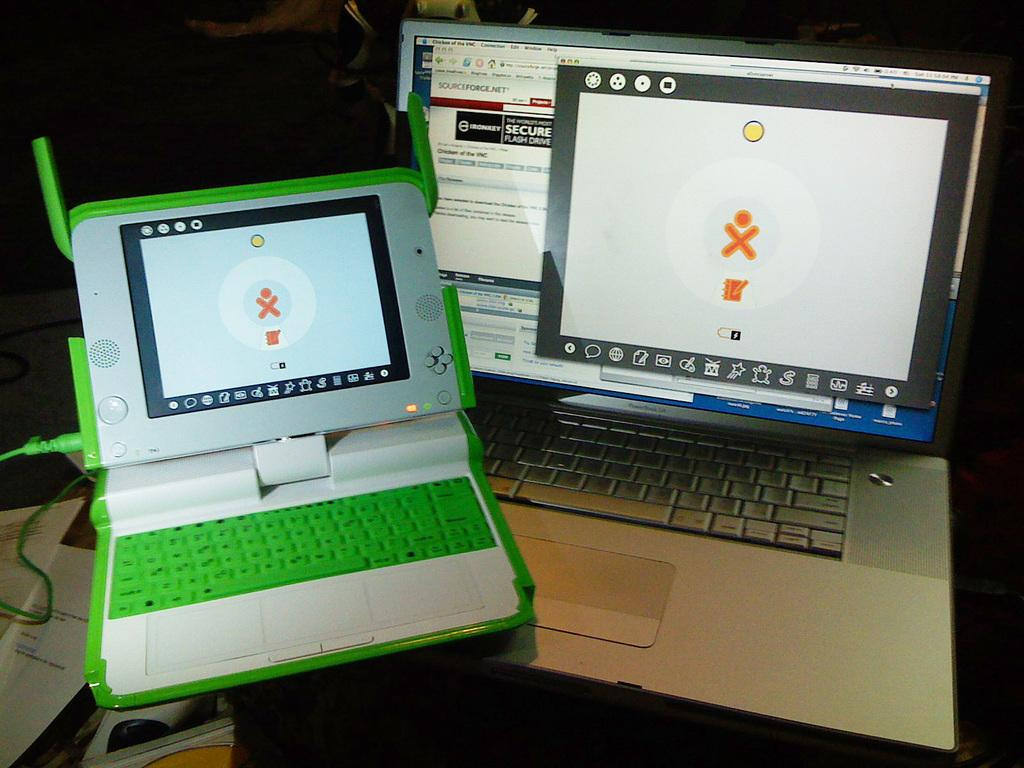<image>
Summarize the visual content of the image. Two laptops, one of which has the words sourceforge.net at the top 